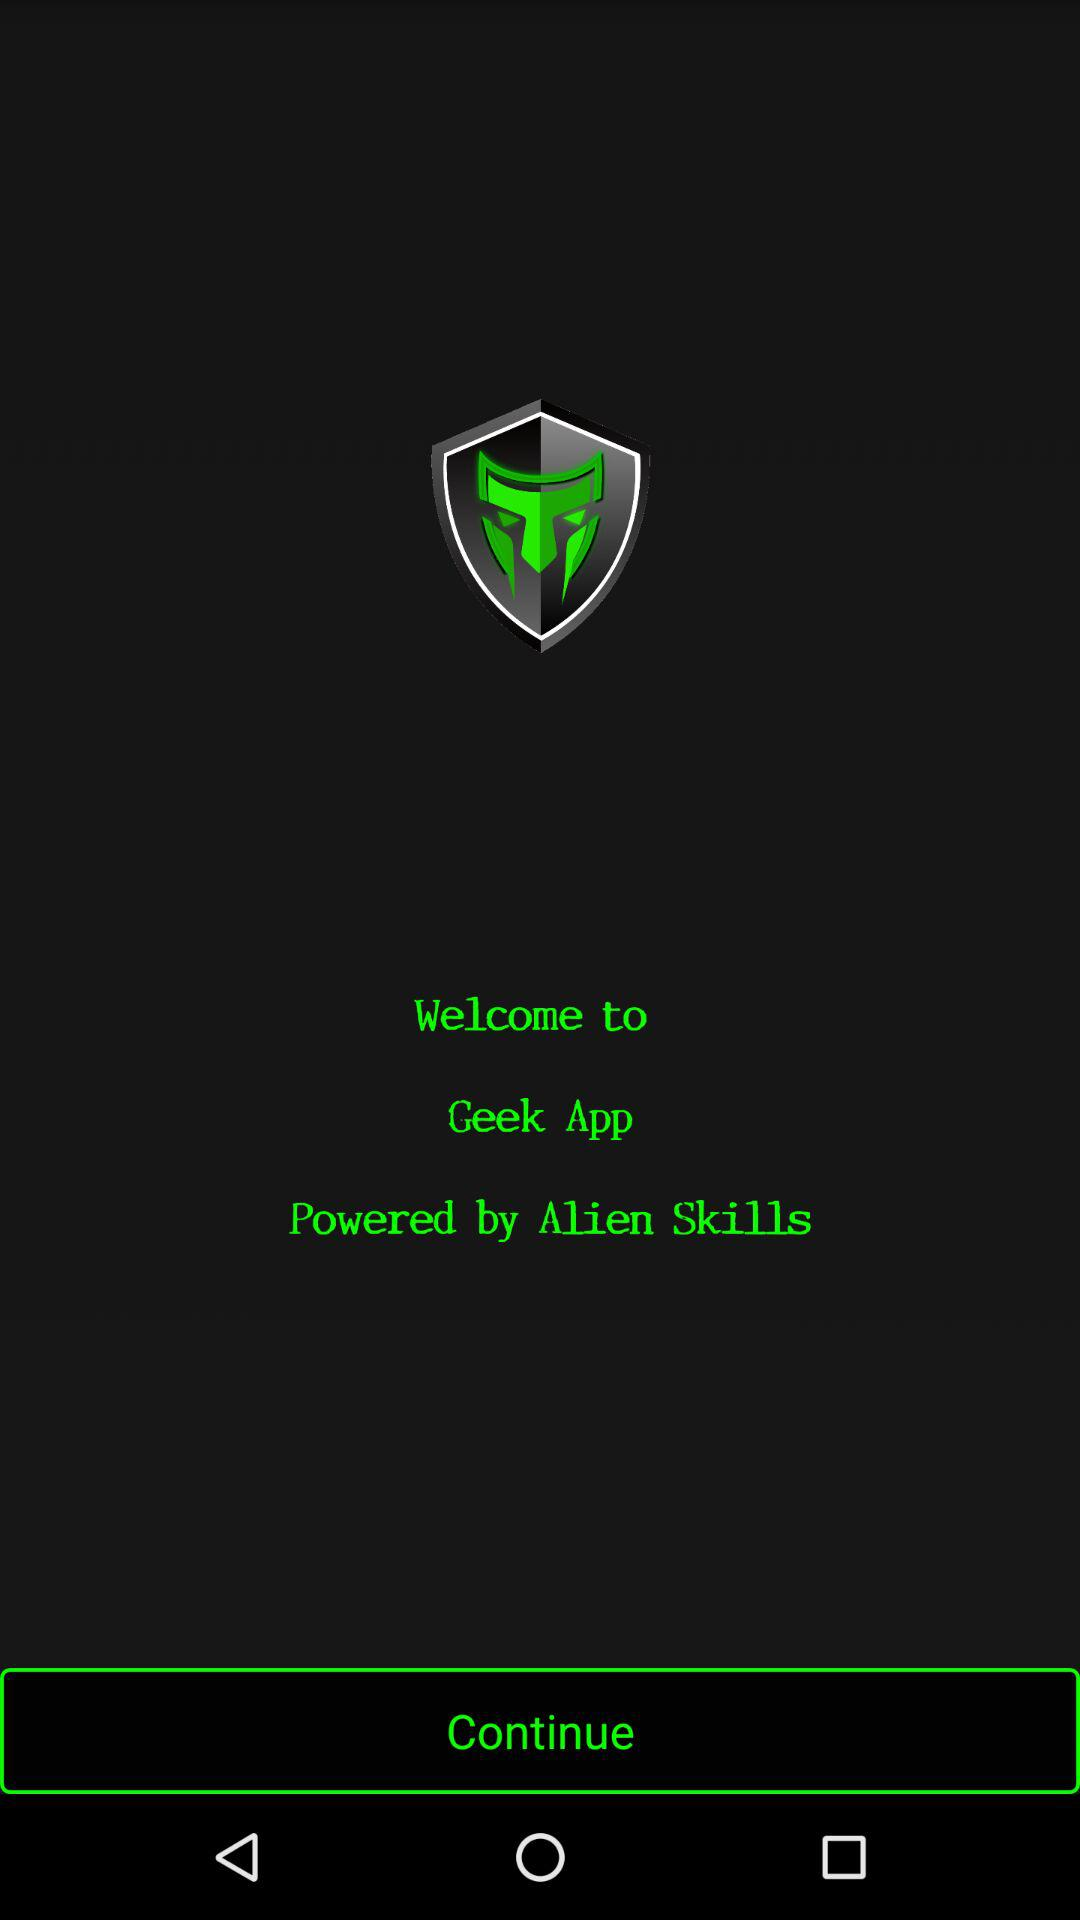The application is powered by which company? The application is powered by Alien Skills. 